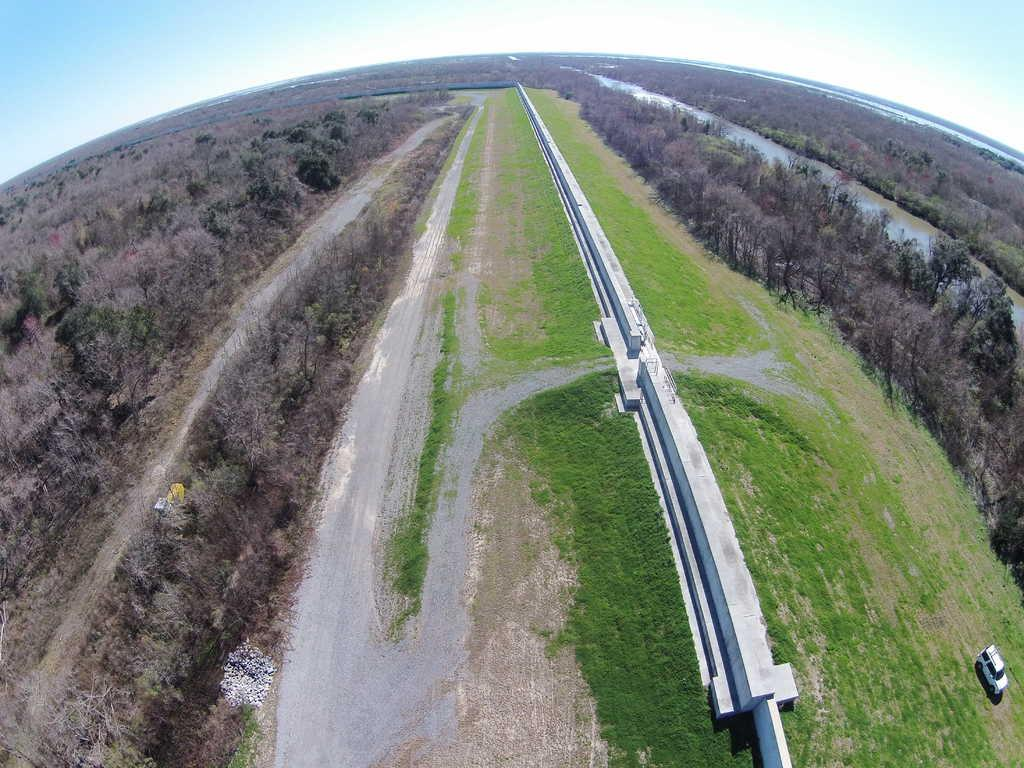What type of vegetation is present on the ground in the image? There is grass on the ground in the image. What can be seen moving on the right side of the image? There is a car moving on the road on the right side of the image. What other natural elements are visible in the image? There are trees in the image. What is the color of the wall in the center of the image? The wall is white in color. What type of pen is the cow holding in the image? There is no cow or pen present in the image. Are there any curtains visible in the image? There are no curtains present in the image. 